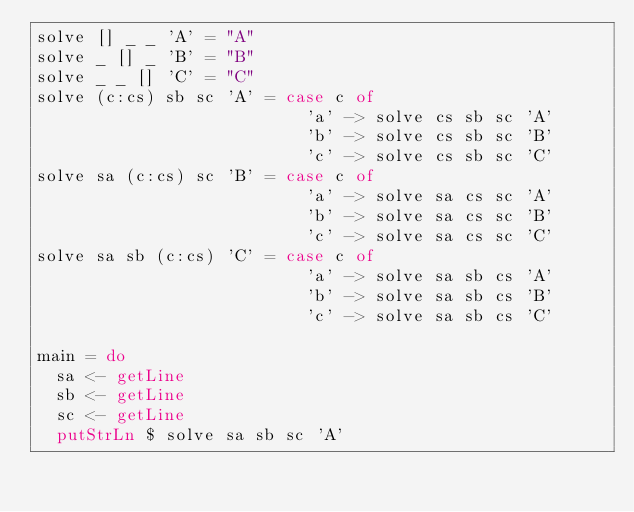<code> <loc_0><loc_0><loc_500><loc_500><_Haskell_>solve [] _ _ 'A' = "A"
solve _ [] _ 'B' = "B"
solve _ _ [] 'C' = "C"
solve (c:cs) sb sc 'A' = case c of
                           'a' -> solve cs sb sc 'A'
                           'b' -> solve cs sb sc 'B'
                           'c' -> solve cs sb sc 'C'
solve sa (c:cs) sc 'B' = case c of
                           'a' -> solve sa cs sc 'A'
                           'b' -> solve sa cs sc 'B'
                           'c' -> solve sa cs sc 'C'
solve sa sb (c:cs) 'C' = case c of
                           'a' -> solve sa sb cs 'A'
                           'b' -> solve sa sb cs 'B'
                           'c' -> solve sa sb cs 'C'

main = do
  sa <- getLine
  sb <- getLine
  sc <- getLine
  putStrLn $ solve sa sb sc 'A'
</code> 